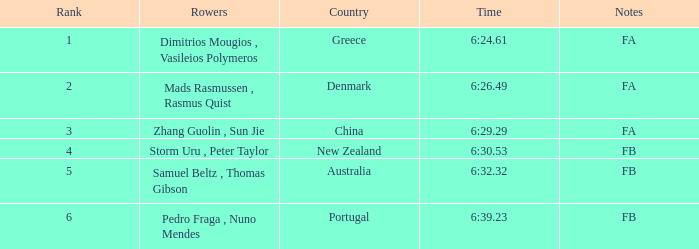What is the names of the rowers that the time was 6:24.61? Dimitrios Mougios , Vasileios Polymeros. 